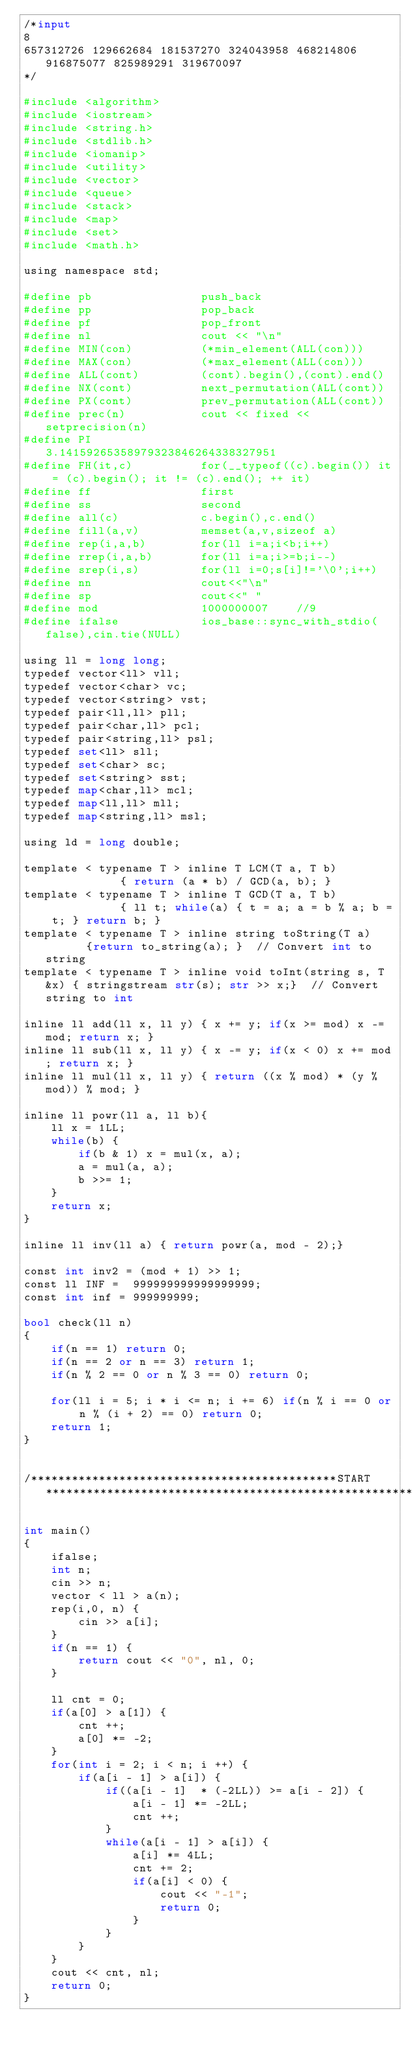<code> <loc_0><loc_0><loc_500><loc_500><_Python_>/*input
8
657312726 129662684 181537270 324043958 468214806 916875077 825989291 319670097
*/

#include <algorithm>
#include <iostream>
#include <string.h>
#include <stdlib.h>
#include <iomanip>
#include <utility>
#include <vector>
#include <queue>
#include <stack>
#include <map>
#include <set>
#include <math.h>

using namespace std;

#define pb                push_back
#define pp                pop_back
#define pf                pop_front
#define nl                cout << "\n"
#define MIN(con)          (*min_element(ALL(con))) 
#define MAX(con)          (*max_element(ALL(con)))
#define ALL(cont)         (cont).begin(),(cont).end()
#define NX(cont)          next_permutation(ALL(cont))
#define PX(cont)          prev_permutation(ALL(cont))
#define prec(n)           cout << fixed << setprecision(n)
#define PI                3.14159265358979323846264338327951
#define FH(it,c)          for(__typeof((c).begin()) it = (c).begin(); it != (c).end(); ++ it)
#define ff                first
#define ss                second
#define all(c)            c.begin(),c.end()
#define fill(a,v)         memset(a,v,sizeof a)
#define rep(i,a,b)        for(ll i=a;i<b;i++)
#define rrep(i,a,b)       for(ll i=a;i>=b;i--)
#define srep(i,s)         for(ll i=0;s[i]!='\0';i++)
#define nn                cout<<"\n"
#define sp                cout<<" "
#define mod               1000000007    //9
#define ifalse            ios_base::sync_with_stdio(false),cin.tie(NULL)

using ll = long long;
typedef vector<ll> vll;
typedef vector<char> vc;
typedef vector<string> vst;
typedef pair<ll,ll> pll;
typedef pair<char,ll> pcl;
typedef pair<string,ll> psl;
typedef set<ll> sll;
typedef set<char> sc;
typedef set<string> sst;
typedef map<char,ll> mcl;
typedef map<ll,ll> mll;
typedef map<string,ll> msl;

using ld = long double;
 
template < typename T > inline T LCM(T a, T b)            { return (a * b) / GCD(a, b); }
template < typename T > inline T GCD(T a, T b)            { ll t; while(a) { t = a; a = b % a; b = t; } return b; }
template < typename T > inline string toString(T a)       {return to_string(a); }  // Convert int to string
template < typename T > inline void toInt(string s, T &x) { stringstream str(s); str >> x;}  // Convert string to int

inline ll add(ll x, ll y) { x += y; if(x >= mod) x -= mod; return x; }
inline ll sub(ll x, ll y) { x -= y; if(x < 0) x += mod; return x; }
inline ll mul(ll x, ll y) { return ((x % mod) * (y % mod)) % mod; }

inline ll powr(ll a, ll b){
    ll x = 1LL;
    while(b) {
        if(b & 1) x = mul(x, a);
        a = mul(a, a);
        b >>= 1;
    }
    return x;
}

inline ll inv(ll a) { return powr(a, mod - 2);}

const int inv2 = (mod + 1) >> 1;
const ll INF =  999999999999999999;
const int inf = 999999999;

bool check(ll n)
{
    if(n == 1) return 0;
    if(n == 2 or n == 3) return 1;
    if(n % 2 == 0 or n % 3 == 0) return 0;

    for(ll i = 5; i * i <= n; i += 6) if(n % i == 0 or n % (i + 2) == 0) return 0;
    return 1;
}


/*********************************************START**************************************************************/

int main()
{
    ifalse;
    int n;
    cin >> n;
    vector < ll > a(n);	
    rep(i,0, n) {
    	cin >> a[i];
    }
    if(n == 1) {
    	return cout << "0", nl, 0;
    } 

    ll cnt = 0;
    if(a[0] > a[1]) {
    	cnt ++;
    	a[0] *= -2;
    }
    for(int i = 2; i < n; i ++) {
    	if(a[i - 1] > a[i]) {
    		if((a[i - 1]  * (-2LL)) >= a[i - 2]) {
    			a[i - 1] *= -2LL;
    			cnt ++;
    		}
    		while(a[i - 1] > a[i]) {
    			a[i] *= 4LL;
    			cnt += 2;
    			if(a[i] < 0) {
    				cout << "-1";
    				return 0;
    			}
    		}
    	}
    }
    cout << cnt, nl;
    return 0;
}</code> 